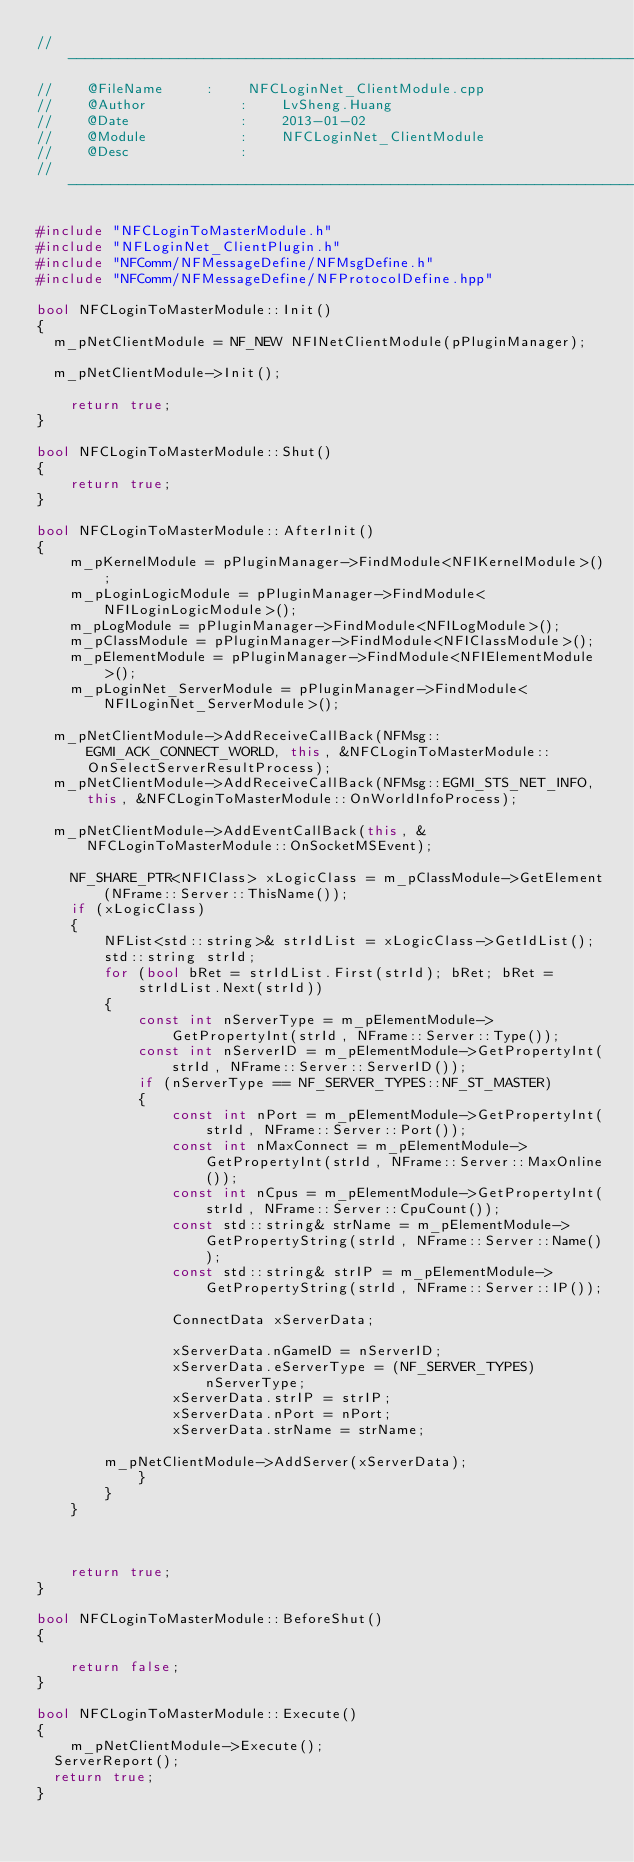Convert code to text. <code><loc_0><loc_0><loc_500><loc_500><_C++_>// -------------------------------------------------------------------------
//    @FileName			:    NFCLoginNet_ClientModule.cpp
//    @Author           :    LvSheng.Huang
//    @Date             :    2013-01-02
//    @Module           :    NFCLoginNet_ClientModule
//    @Desc             :
// -------------------------------------------------------------------------

#include "NFCLoginToMasterModule.h"
#include "NFLoginNet_ClientPlugin.h"
#include "NFComm/NFMessageDefine/NFMsgDefine.h"
#include "NFComm/NFMessageDefine/NFProtocolDefine.hpp"

bool NFCLoginToMasterModule::Init()
{
	m_pNetClientModule = NF_NEW NFINetClientModule(pPluginManager);

	m_pNetClientModule->Init();

    return true;
}

bool NFCLoginToMasterModule::Shut()
{
    return true;
}

bool NFCLoginToMasterModule::AfterInit()
{
    m_pKernelModule = pPluginManager->FindModule<NFIKernelModule>();
    m_pLoginLogicModule = pPluginManager->FindModule<NFILoginLogicModule>();
    m_pLogModule = pPluginManager->FindModule<NFILogModule>();
    m_pClassModule = pPluginManager->FindModule<NFIClassModule>();
    m_pElementModule = pPluginManager->FindModule<NFIElementModule>();
    m_pLoginNet_ServerModule = pPluginManager->FindModule<NFILoginNet_ServerModule>();

	m_pNetClientModule->AddReceiveCallBack(NFMsg::EGMI_ACK_CONNECT_WORLD, this, &NFCLoginToMasterModule::OnSelectServerResultProcess);
	m_pNetClientModule->AddReceiveCallBack(NFMsg::EGMI_STS_NET_INFO, this, &NFCLoginToMasterModule::OnWorldInfoProcess);
	
	m_pNetClientModule->AddEventCallBack(this, &NFCLoginToMasterModule::OnSocketMSEvent);

    NF_SHARE_PTR<NFIClass> xLogicClass = m_pClassModule->GetElement(NFrame::Server::ThisName());
    if (xLogicClass)
    {
        NFList<std::string>& strIdList = xLogicClass->GetIdList();
        std::string strId;
        for (bool bRet = strIdList.First(strId); bRet; bRet = strIdList.Next(strId))
        {
            const int nServerType = m_pElementModule->GetPropertyInt(strId, NFrame::Server::Type());
            const int nServerID = m_pElementModule->GetPropertyInt(strId, NFrame::Server::ServerID());
            if (nServerType == NF_SERVER_TYPES::NF_ST_MASTER)
            {
                const int nPort = m_pElementModule->GetPropertyInt(strId, NFrame::Server::Port());
                const int nMaxConnect = m_pElementModule->GetPropertyInt(strId, NFrame::Server::MaxOnline());
                const int nCpus = m_pElementModule->GetPropertyInt(strId, NFrame::Server::CpuCount());
                const std::string& strName = m_pElementModule->GetPropertyString(strId, NFrame::Server::Name());
                const std::string& strIP = m_pElementModule->GetPropertyString(strId, NFrame::Server::IP());

                ConnectData xServerData;

                xServerData.nGameID = nServerID;
                xServerData.eServerType = (NF_SERVER_TYPES)nServerType;
                xServerData.strIP = strIP;
                xServerData.nPort = nPort;
                xServerData.strName = strName;

				m_pNetClientModule->AddServer(xServerData);
            }
        }
    }



    return true;
}

bool NFCLoginToMasterModule::BeforeShut()
{

    return false;
}

bool NFCLoginToMasterModule::Execute()
{
    m_pNetClientModule->Execute();
	ServerReport();
	return true;
}
</code> 